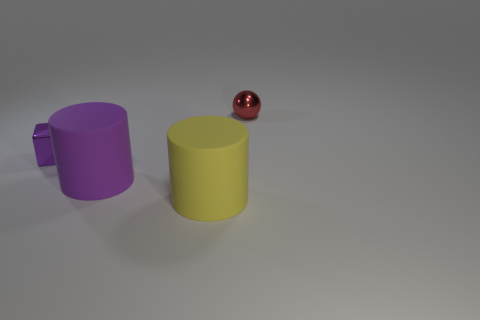Are there any yellow rubber things that have the same shape as the big purple matte thing?
Offer a terse response. Yes. Do the tiny metallic object that is to the left of the small sphere and the matte thing that is on the right side of the purple matte cylinder have the same shape?
Offer a terse response. No. There is a ball that is the same size as the shiny cube; what is its material?
Ensure brevity in your answer.  Metal. What number of other objects are the same material as the yellow cylinder?
Give a very brief answer. 1. What shape is the small thing on the left side of the purple thing that is on the right side of the purple cube?
Offer a very short reply. Cube. What number of things are small purple metallic objects or small objects left of the large purple matte cylinder?
Your answer should be compact. 1. How many other objects are there of the same color as the sphere?
Provide a succinct answer. 0. How many brown objects are rubber cylinders or small things?
Ensure brevity in your answer.  0. There is a metal object that is right of the purple shiny block in front of the red metallic object; are there any tiny shiny things in front of it?
Make the answer very short. Yes. Is there anything else that is the same size as the cube?
Your answer should be compact. Yes. 